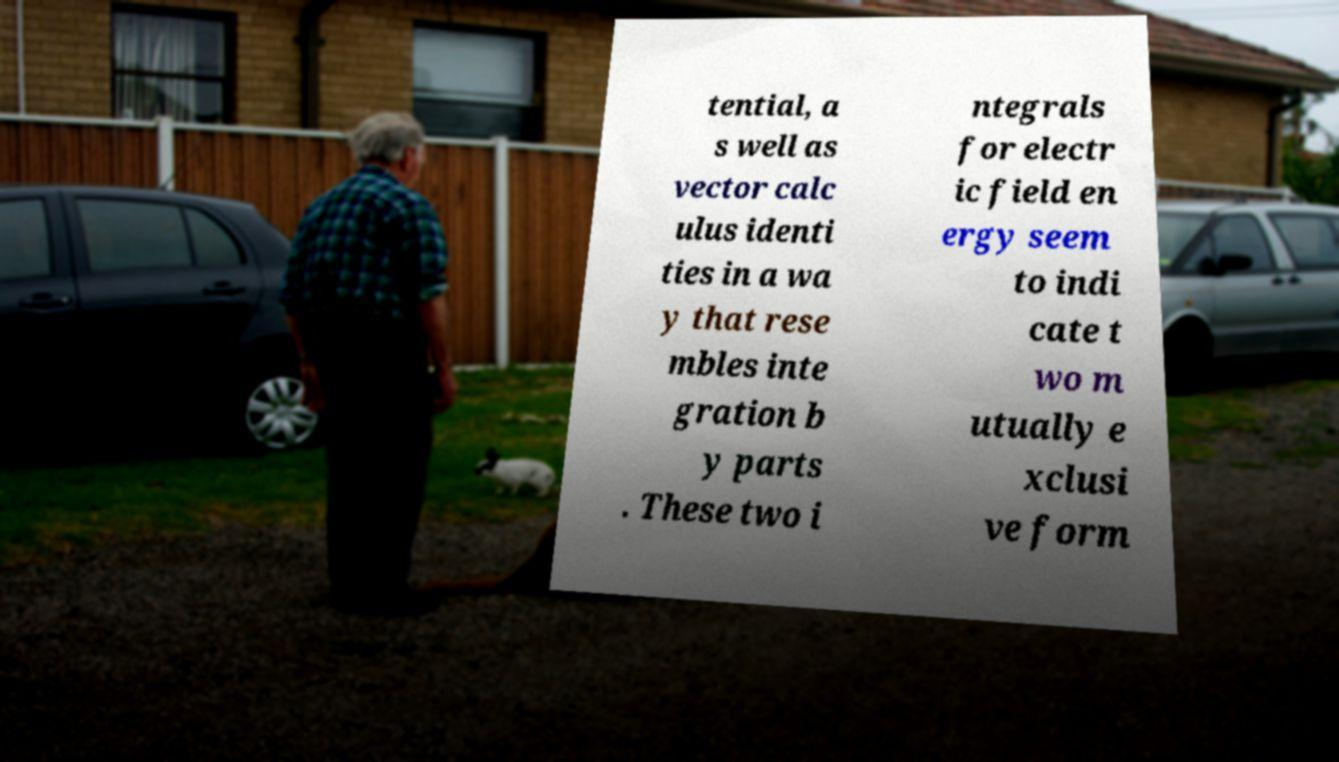Please identify and transcribe the text found in this image. tential, a s well as vector calc ulus identi ties in a wa y that rese mbles inte gration b y parts . These two i ntegrals for electr ic field en ergy seem to indi cate t wo m utually e xclusi ve form 